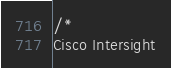<code> <loc_0><loc_0><loc_500><loc_500><_Go_>/*
Cisco Intersight
</code> 